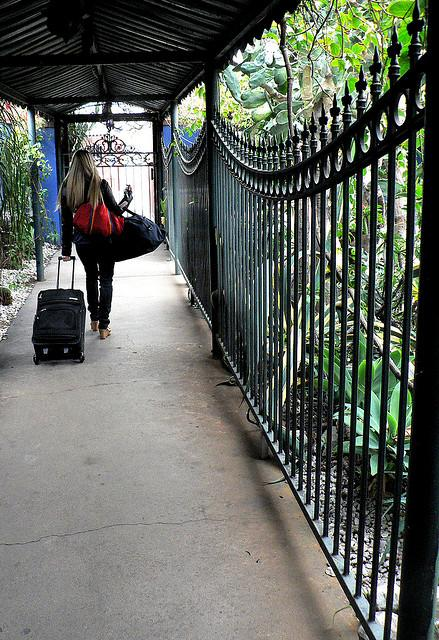Where is the woman likely heading? Please explain your reasoning. vacation. The woman is holding a suitcase. 